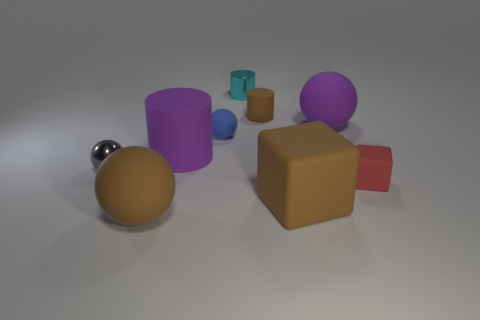Is there another object that has the same shape as the red thing?
Your answer should be very brief. Yes. There is a brown rubber object behind the small red rubber cube; is it the same shape as the large purple thing that is to the left of the tiny cyan metal cylinder?
Ensure brevity in your answer.  Yes. There is a gray thing that is the same size as the metallic cylinder; what is its material?
Provide a succinct answer. Metal. How many other things are made of the same material as the cyan thing?
Provide a succinct answer. 1. What is the shape of the cyan object on the left side of the small thing on the right side of the brown cylinder?
Keep it short and to the point. Cylinder. How many things are big blue cylinders or matte cylinders that are on the left side of the tiny rubber sphere?
Your answer should be compact. 1. What number of other things are there of the same color as the small matte cylinder?
Provide a succinct answer. 2. What number of purple things are either cylinders or big matte cylinders?
Make the answer very short. 1. There is a tiny metal object in front of the shiny object behind the metallic sphere; are there any brown objects that are in front of it?
Give a very brief answer. Yes. Do the small shiny ball and the tiny rubber sphere have the same color?
Your answer should be very brief. No. 